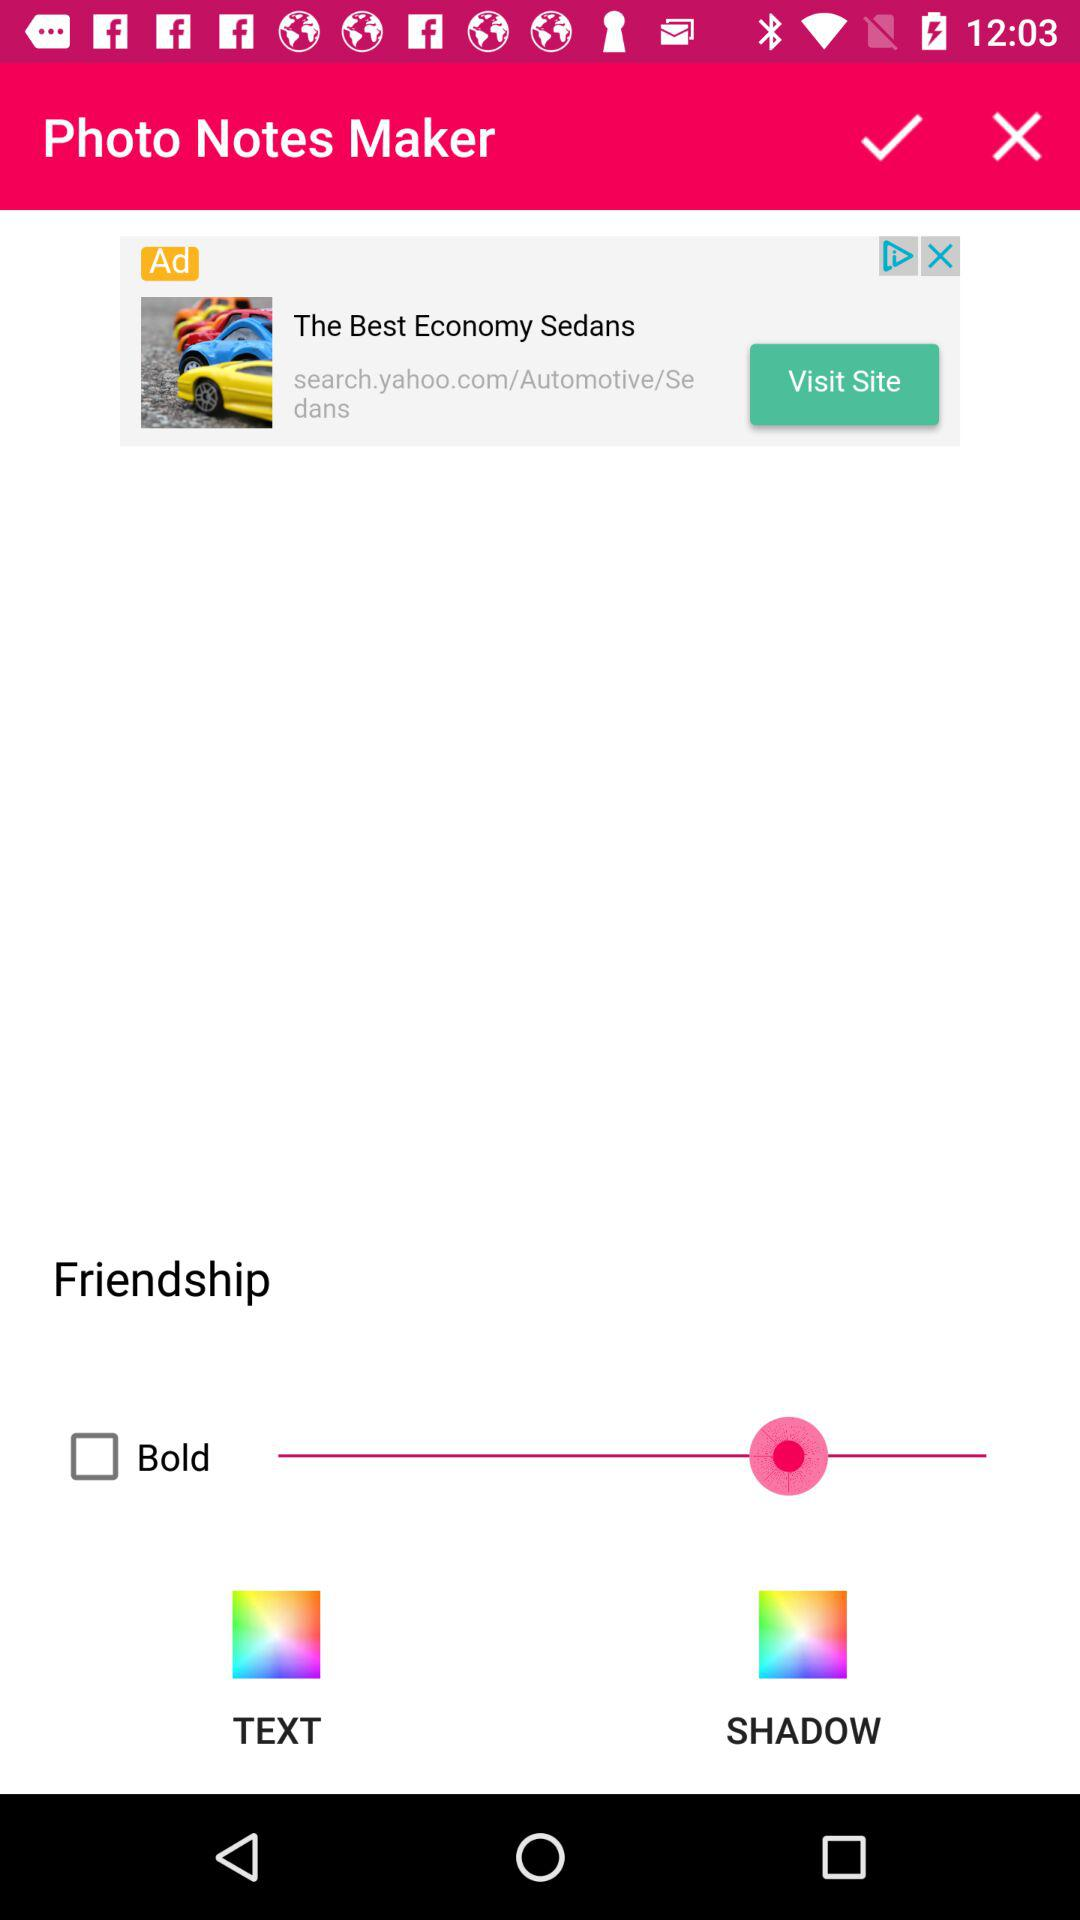What is the name of the application? The name of the application is "Photo Notes Maker". 